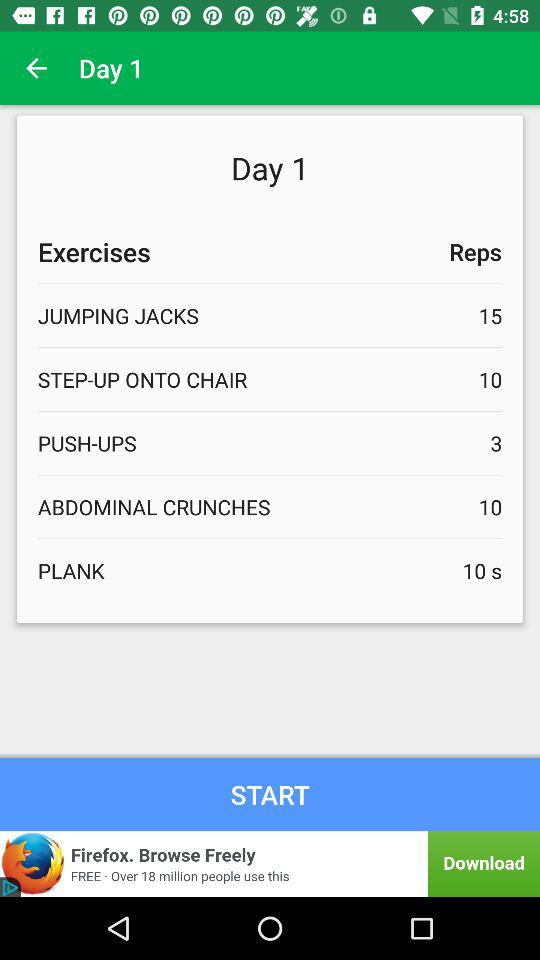How many reps for jumping jacks on day 1? There are 15 reps for jumping jacks on day 1. 